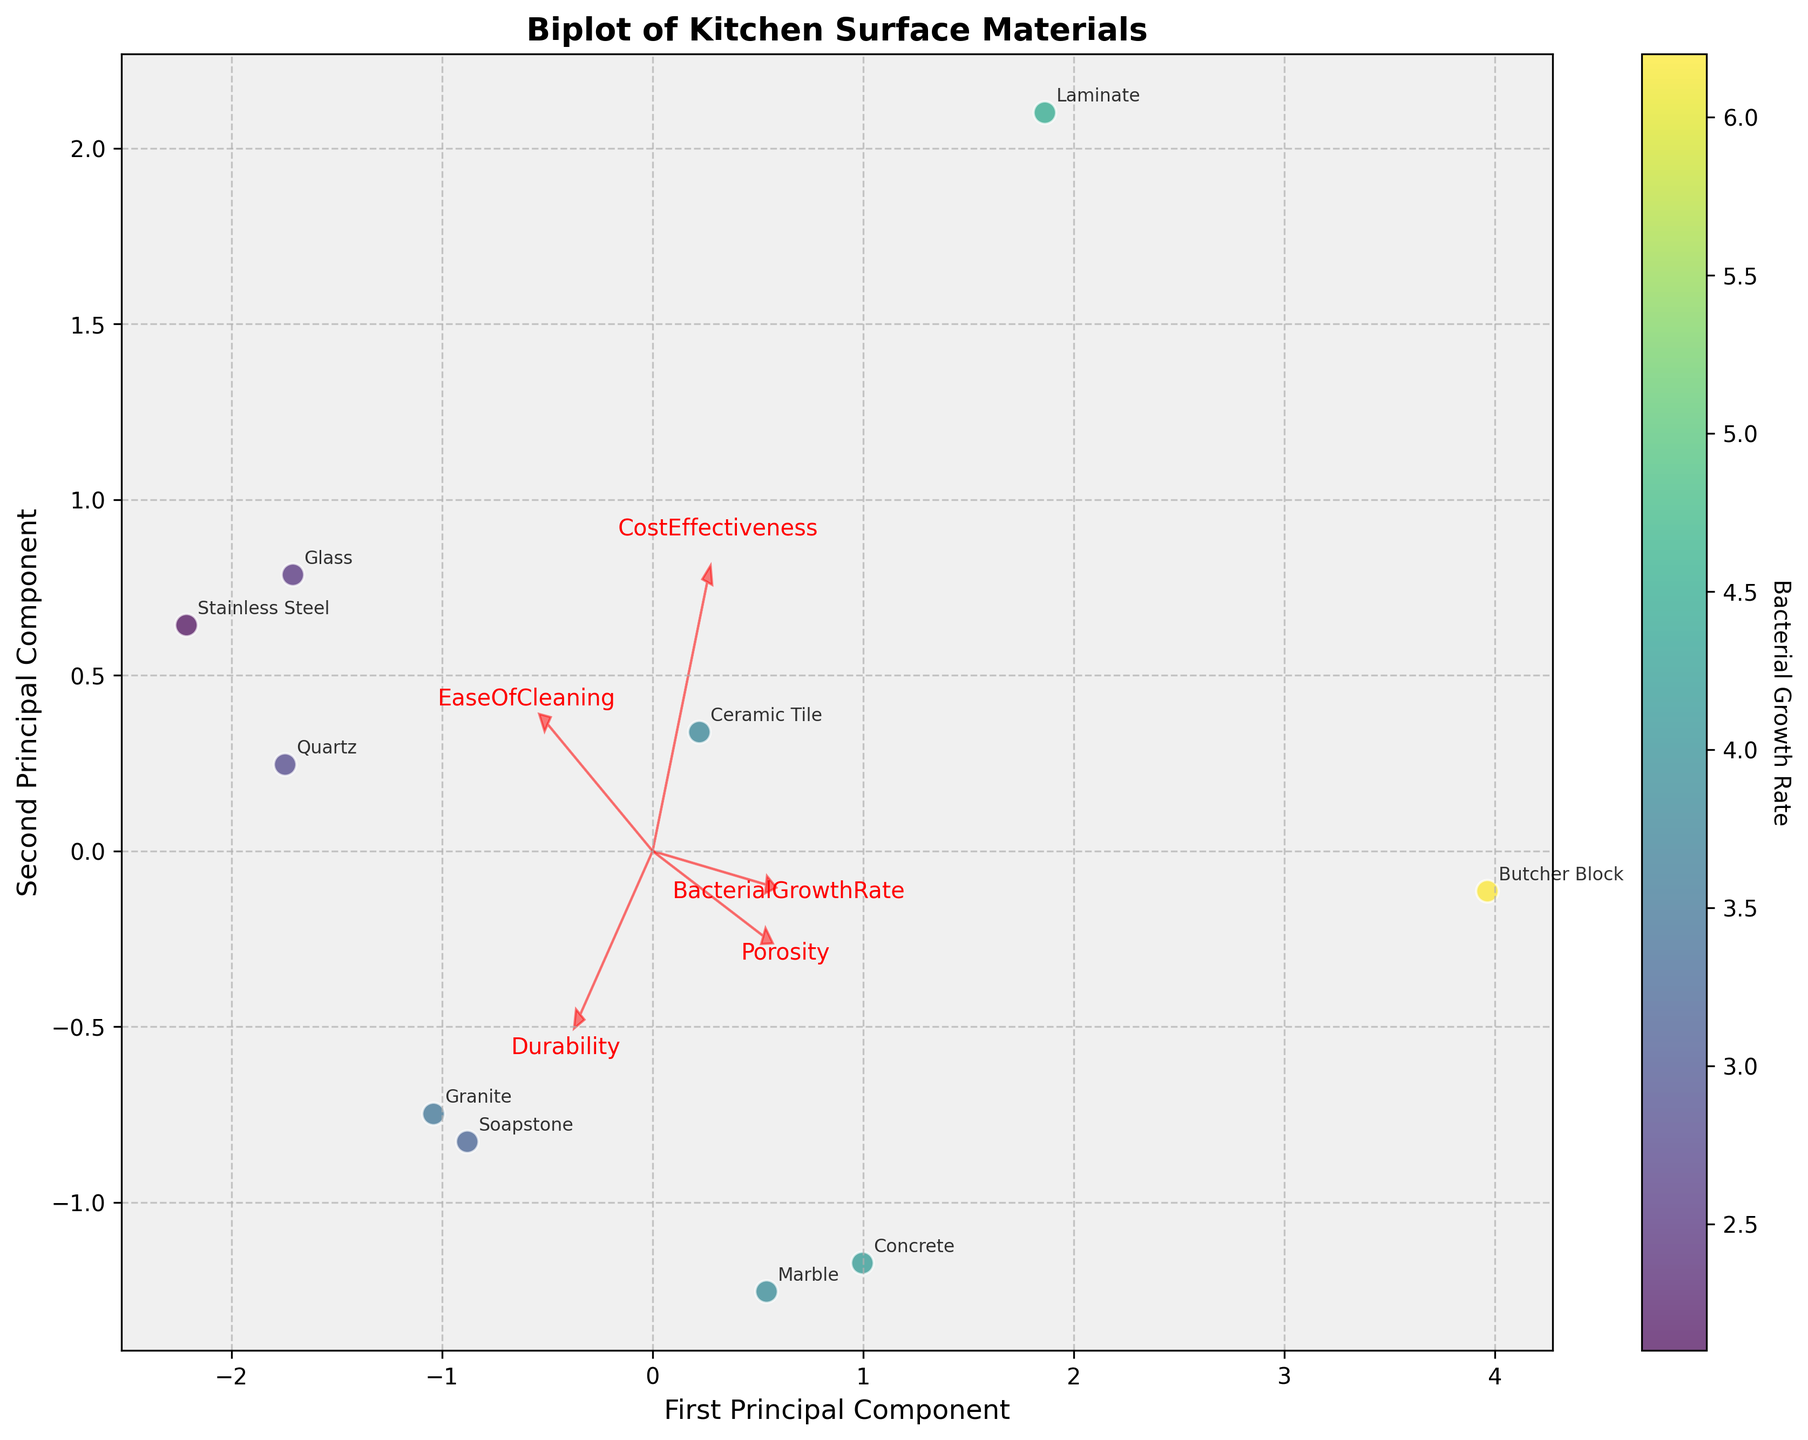what is the title of the biplot? The title of the biplot is typically prominent and displayed at the top of the figure. Looking at the figure, the title is "Biplot of Kitchen Surface Materials."
Answer: Biplot of Kitchen Surface Materials What are the axes labels on the biplot? The axes labels typically describe the dimensions represented in the plot. In this case, they are "First Principal Component" for the x-axis and "Second Principal Component" for the y-axis.
Answer: First Principal Component and Second Principal Component How many materials are plotted on the biplot? Each material is represented by a labeled data point. Count the number of labeled points on the plot. There are ten materials displayed.
Answer: 10 Which material has the lowest bacterial growth rate on the biplot? The color bar represents the bacterial growth rate, and the material with the darkest (or coldest) color will have the lowest bacterial growth rate. Stainless Steel has the lowest bacterial growth rate.
Answer: Stainless Steel Which material has the highest porosity on the biplot? The feature vectors indicate the direction and magnitude of features like porosity. Identify the material farthest along the porosity vector. Butcher Block has the highest porosity.
Answer: Butcher Block How does ease of cleaning generally relate to bacterial growth rate based on the biplot? Look at the feature vectors for Ease Of Cleaning and Bacterial Growth Rate to see if they point in similar or opposite directions. They generally point in opposite directions, suggesting that higher ease of cleaning tends to correspond with lower bacterial growth rates.
Answer: Negatively correlated Which materials are closest to the durability vector? Observe which data points are most aligned or closest to the direction of the durability vector. Stainless Steel and Quartz are closest to the durability vector.
Answer: Stainless Steel and Quartz Which material has the highest value in the first principal component? Look at the x-coordinates of the data points and identify the material with the highest value on the x-axis (First Principal Component). Butcher Block has the highest value in the first principal component.
Answer: Butcher Block Are there any materials that appear to balance cost-effectiveness and ease of cleaning well? Examine how close the materials are to both the cost-effectiveness and ease of cleaning vectors on the biplot. Materials like Laminate appear to balance these two features well.
Answer: Laminate What material balances well between durability and cost-effectiveness based on their vectors? Assess which material lies approximately midway along the vectors for durability and cost-effectiveness by visually balancing their directions and magnitudes. Quartz seems to balance well between these two features.
Answer: Quartz 